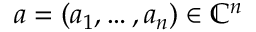<formula> <loc_0><loc_0><loc_500><loc_500>a = ( a _ { 1 } , \dots , a _ { n } ) \in \mathbb { C } ^ { n }</formula> 